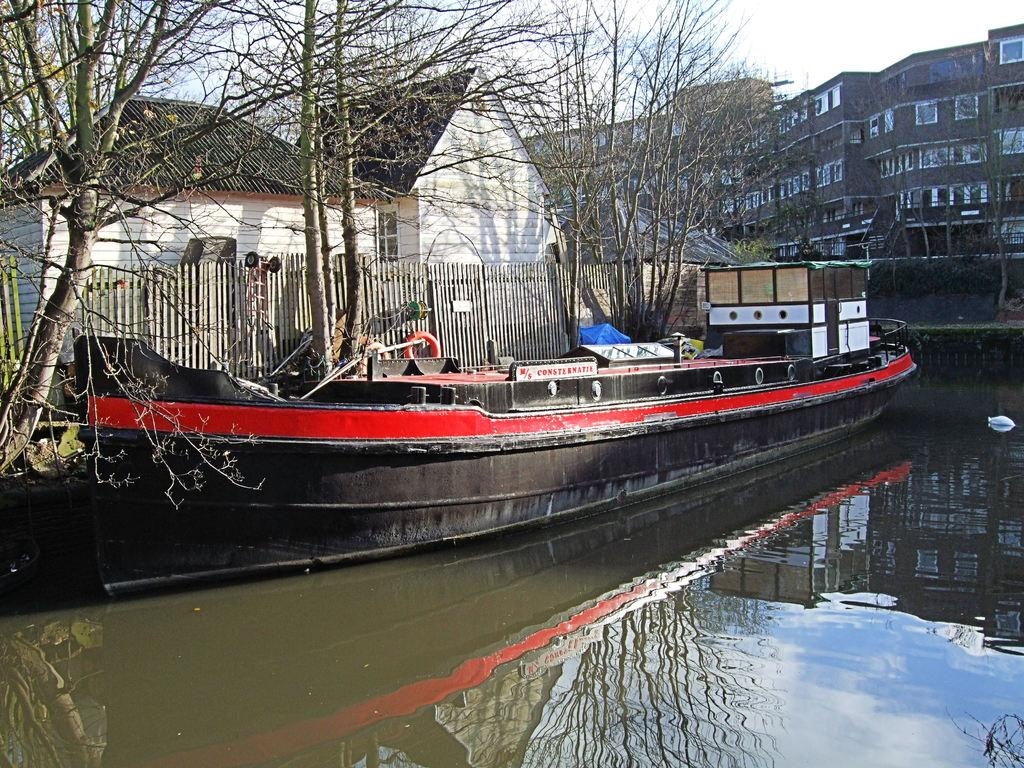What is located above the water in the image? There is a boat above the water in the image. What type of structure can be seen in the image? There is a shed in the image. What type of vegetation is present in the image? Trees are present in the image. What type of barrier is visible in the image? There is wooden fencing in the image. What type of residential structures are visible in the image? Houses are visible in the image. What type of structures are present in the image? Buildings are present in the image. What type of architectural elements are visible in the image? Walls are visible in the image. What type of openings are present in the structures in the image? Windows are present in the image. What is visible at the top of the image? The sky is visible at the top of the image. How does the boat get its power from the cord in the image? There is no cord present in the image, and the boat does not appear to be powered by any visible means. What type of wind can be seen blowing through the windows in the image? There is no wind or blowing visible through the windows in the image; the windows are stationary. 